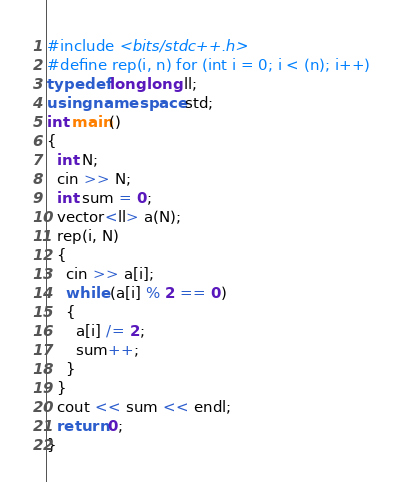<code> <loc_0><loc_0><loc_500><loc_500><_C++_>#include <bits/stdc++.h>
#define rep(i, n) for (int i = 0; i < (n); i++)
typedef long long ll;
using namespace std;
int main()
{
  int N;
  cin >> N;
  int sum = 0;
  vector<ll> a(N);
  rep(i, N)
  {
    cin >> a[i];
    while (a[i] % 2 == 0)
    {
      a[i] /= 2;
      sum++;
    }
  }
  cout << sum << endl;
  return 0;
}</code> 